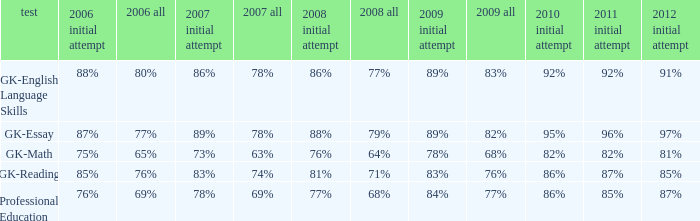What is the percentage for all 2008 when all in 2007 is 69%? 68%. 